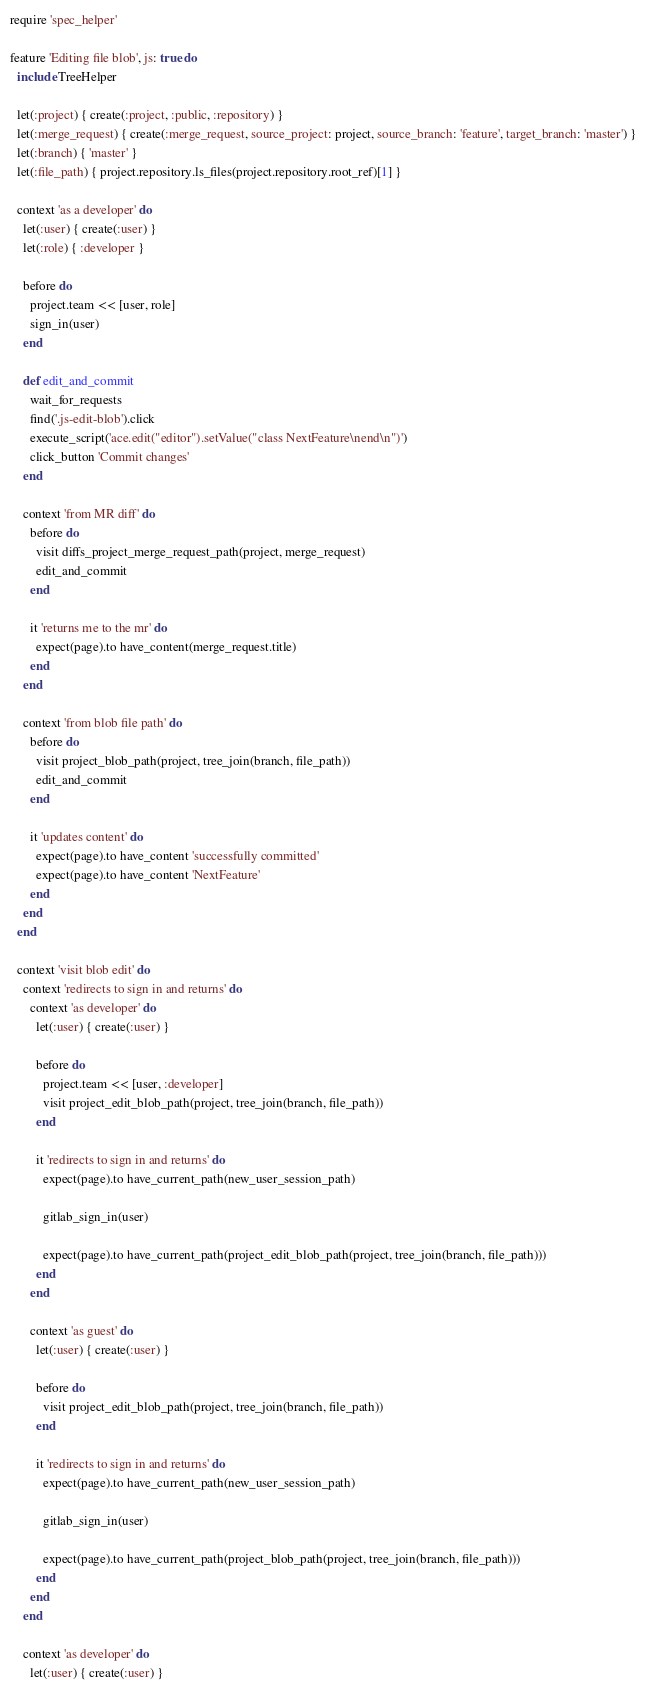<code> <loc_0><loc_0><loc_500><loc_500><_Ruby_>require 'spec_helper'

feature 'Editing file blob', js: true do
  include TreeHelper

  let(:project) { create(:project, :public, :repository) }
  let(:merge_request) { create(:merge_request, source_project: project, source_branch: 'feature', target_branch: 'master') }
  let(:branch) { 'master' }
  let(:file_path) { project.repository.ls_files(project.repository.root_ref)[1] }

  context 'as a developer' do
    let(:user) { create(:user) }
    let(:role) { :developer }

    before do
      project.team << [user, role]
      sign_in(user)
    end

    def edit_and_commit
      wait_for_requests
      find('.js-edit-blob').click
      execute_script('ace.edit("editor").setValue("class NextFeature\nend\n")')
      click_button 'Commit changes'
    end

    context 'from MR diff' do
      before do
        visit diffs_project_merge_request_path(project, merge_request)
        edit_and_commit
      end

      it 'returns me to the mr' do
        expect(page).to have_content(merge_request.title)
      end
    end

    context 'from blob file path' do
      before do
        visit project_blob_path(project, tree_join(branch, file_path))
        edit_and_commit
      end

      it 'updates content' do
        expect(page).to have_content 'successfully committed'
        expect(page).to have_content 'NextFeature'
      end
    end
  end

  context 'visit blob edit' do
    context 'redirects to sign in and returns' do
      context 'as developer' do
        let(:user) { create(:user) }

        before do
          project.team << [user, :developer]
          visit project_edit_blob_path(project, tree_join(branch, file_path))
        end

        it 'redirects to sign in and returns' do
          expect(page).to have_current_path(new_user_session_path)

          gitlab_sign_in(user)

          expect(page).to have_current_path(project_edit_blob_path(project, tree_join(branch, file_path)))
        end
      end

      context 'as guest' do
        let(:user) { create(:user) }

        before do
          visit project_edit_blob_path(project, tree_join(branch, file_path))
        end

        it 'redirects to sign in and returns' do
          expect(page).to have_current_path(new_user_session_path)

          gitlab_sign_in(user)

          expect(page).to have_current_path(project_blob_path(project, tree_join(branch, file_path)))
        end
      end
    end

    context 'as developer' do
      let(:user) { create(:user) }</code> 